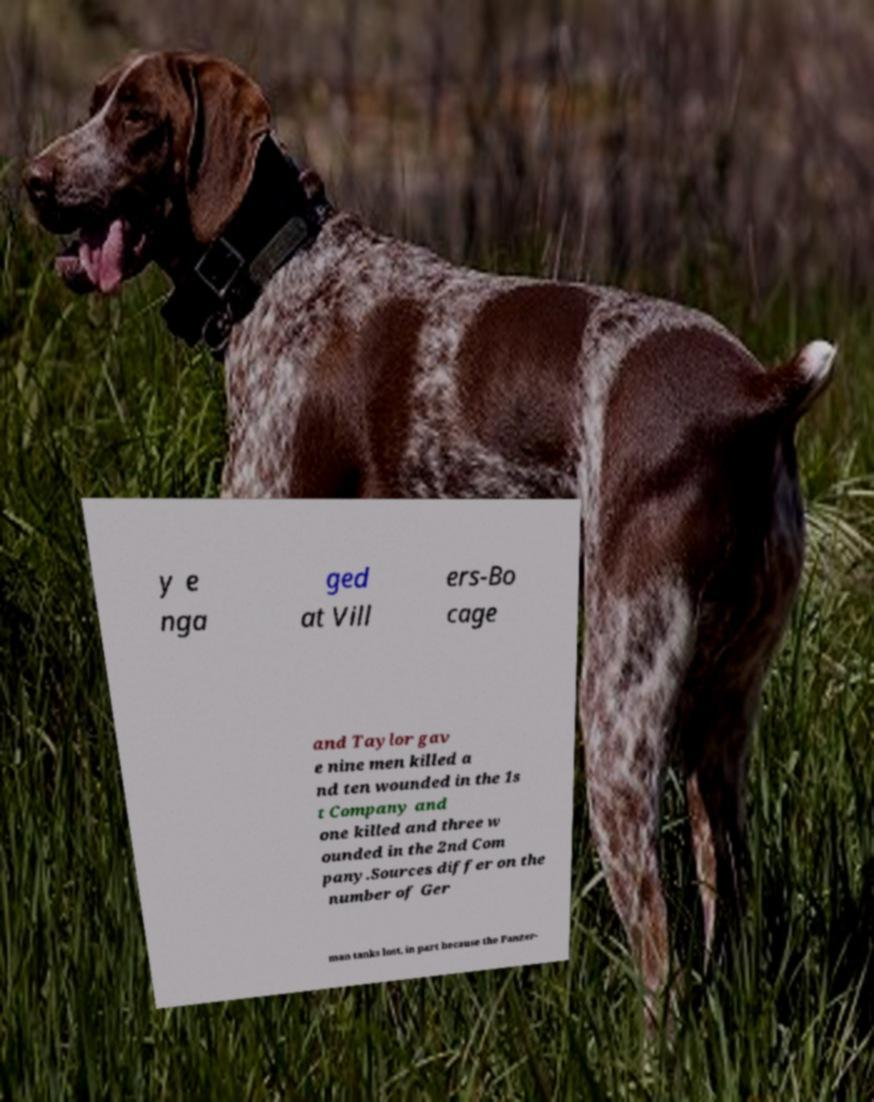Could you assist in decoding the text presented in this image and type it out clearly? y e nga ged at Vill ers-Bo cage and Taylor gav e nine men killed a nd ten wounded in the 1s t Company and one killed and three w ounded in the 2nd Com pany.Sources differ on the number of Ger man tanks lost, in part because the Panzer- 